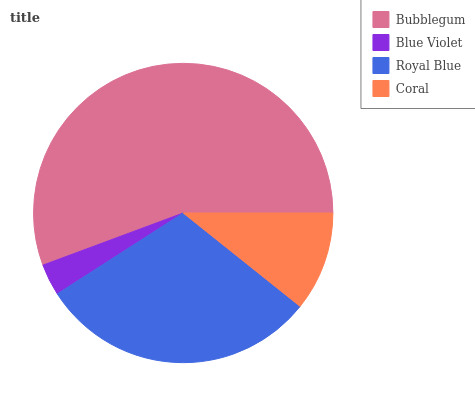Is Blue Violet the minimum?
Answer yes or no. Yes. Is Bubblegum the maximum?
Answer yes or no. Yes. Is Royal Blue the minimum?
Answer yes or no. No. Is Royal Blue the maximum?
Answer yes or no. No. Is Royal Blue greater than Blue Violet?
Answer yes or no. Yes. Is Blue Violet less than Royal Blue?
Answer yes or no. Yes. Is Blue Violet greater than Royal Blue?
Answer yes or no. No. Is Royal Blue less than Blue Violet?
Answer yes or no. No. Is Royal Blue the high median?
Answer yes or no. Yes. Is Coral the low median?
Answer yes or no. Yes. Is Bubblegum the high median?
Answer yes or no. No. Is Royal Blue the low median?
Answer yes or no. No. 